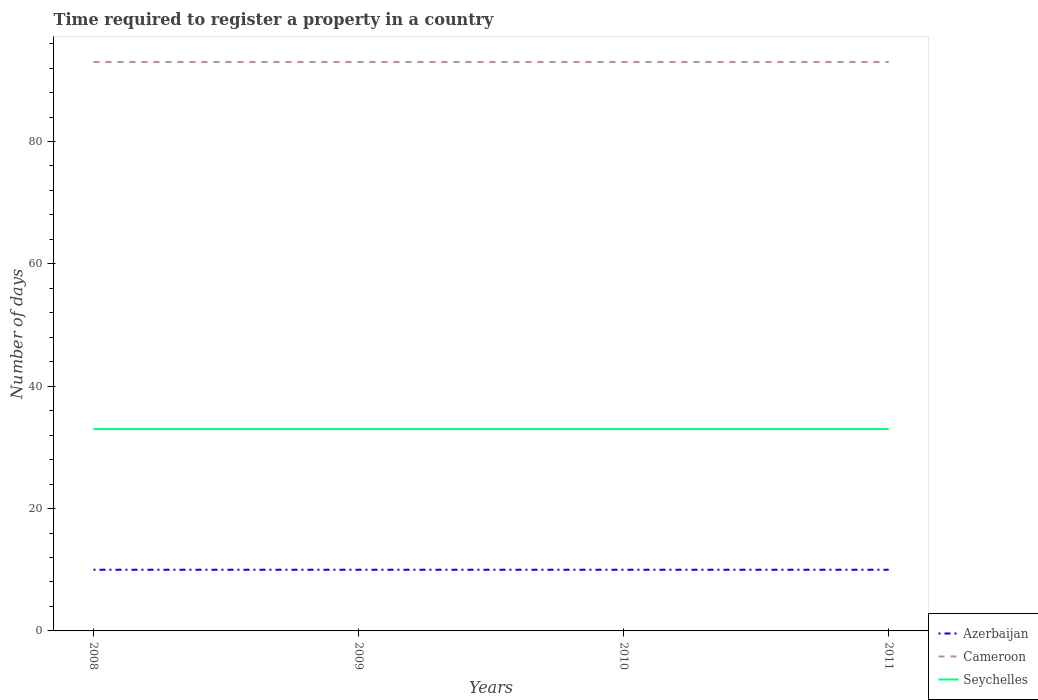How many different coloured lines are there?
Offer a terse response. 3. Is the number of lines equal to the number of legend labels?
Provide a succinct answer. Yes. In which year was the number of days required to register a property in Azerbaijan maximum?
Ensure brevity in your answer.  2008. What is the total number of days required to register a property in Azerbaijan in the graph?
Keep it short and to the point. 0. What is the difference between the highest and the second highest number of days required to register a property in Cameroon?
Make the answer very short. 0. How many lines are there?
Offer a very short reply. 3. How many years are there in the graph?
Provide a succinct answer. 4. What is the difference between two consecutive major ticks on the Y-axis?
Keep it short and to the point. 20. Are the values on the major ticks of Y-axis written in scientific E-notation?
Your response must be concise. No. What is the title of the graph?
Your answer should be compact. Time required to register a property in a country. What is the label or title of the X-axis?
Offer a terse response. Years. What is the label or title of the Y-axis?
Offer a terse response. Number of days. What is the Number of days in Azerbaijan in 2008?
Provide a succinct answer. 10. What is the Number of days in Cameroon in 2008?
Offer a very short reply. 93. What is the Number of days of Cameroon in 2009?
Provide a succinct answer. 93. What is the Number of days in Azerbaijan in 2010?
Offer a terse response. 10. What is the Number of days in Cameroon in 2010?
Provide a short and direct response. 93. What is the Number of days of Azerbaijan in 2011?
Your answer should be very brief. 10. What is the Number of days in Cameroon in 2011?
Your answer should be very brief. 93. Across all years, what is the maximum Number of days in Azerbaijan?
Provide a succinct answer. 10. Across all years, what is the maximum Number of days of Cameroon?
Give a very brief answer. 93. Across all years, what is the minimum Number of days in Azerbaijan?
Make the answer very short. 10. Across all years, what is the minimum Number of days of Cameroon?
Give a very brief answer. 93. Across all years, what is the minimum Number of days of Seychelles?
Provide a succinct answer. 33. What is the total Number of days of Cameroon in the graph?
Make the answer very short. 372. What is the total Number of days of Seychelles in the graph?
Ensure brevity in your answer.  132. What is the difference between the Number of days of Seychelles in 2008 and that in 2009?
Your response must be concise. 0. What is the difference between the Number of days of Azerbaijan in 2008 and that in 2010?
Provide a short and direct response. 0. What is the difference between the Number of days in Cameroon in 2008 and that in 2010?
Keep it short and to the point. 0. What is the difference between the Number of days of Azerbaijan in 2008 and that in 2011?
Your answer should be very brief. 0. What is the difference between the Number of days of Cameroon in 2008 and that in 2011?
Offer a terse response. 0. What is the difference between the Number of days in Azerbaijan in 2009 and that in 2010?
Ensure brevity in your answer.  0. What is the difference between the Number of days of Azerbaijan in 2010 and that in 2011?
Ensure brevity in your answer.  0. What is the difference between the Number of days of Cameroon in 2010 and that in 2011?
Your answer should be compact. 0. What is the difference between the Number of days in Azerbaijan in 2008 and the Number of days in Cameroon in 2009?
Offer a terse response. -83. What is the difference between the Number of days in Azerbaijan in 2008 and the Number of days in Seychelles in 2009?
Ensure brevity in your answer.  -23. What is the difference between the Number of days of Cameroon in 2008 and the Number of days of Seychelles in 2009?
Give a very brief answer. 60. What is the difference between the Number of days in Azerbaijan in 2008 and the Number of days in Cameroon in 2010?
Your response must be concise. -83. What is the difference between the Number of days of Azerbaijan in 2008 and the Number of days of Cameroon in 2011?
Make the answer very short. -83. What is the difference between the Number of days in Cameroon in 2008 and the Number of days in Seychelles in 2011?
Your answer should be very brief. 60. What is the difference between the Number of days of Azerbaijan in 2009 and the Number of days of Cameroon in 2010?
Ensure brevity in your answer.  -83. What is the difference between the Number of days in Azerbaijan in 2009 and the Number of days in Seychelles in 2010?
Make the answer very short. -23. What is the difference between the Number of days of Azerbaijan in 2009 and the Number of days of Cameroon in 2011?
Your answer should be very brief. -83. What is the difference between the Number of days in Azerbaijan in 2009 and the Number of days in Seychelles in 2011?
Offer a very short reply. -23. What is the difference between the Number of days of Azerbaijan in 2010 and the Number of days of Cameroon in 2011?
Provide a succinct answer. -83. What is the average Number of days of Cameroon per year?
Your answer should be compact. 93. What is the average Number of days of Seychelles per year?
Give a very brief answer. 33. In the year 2008, what is the difference between the Number of days in Azerbaijan and Number of days in Cameroon?
Your response must be concise. -83. In the year 2008, what is the difference between the Number of days in Cameroon and Number of days in Seychelles?
Make the answer very short. 60. In the year 2009, what is the difference between the Number of days in Azerbaijan and Number of days in Cameroon?
Your answer should be very brief. -83. In the year 2009, what is the difference between the Number of days of Azerbaijan and Number of days of Seychelles?
Provide a short and direct response. -23. In the year 2009, what is the difference between the Number of days in Cameroon and Number of days in Seychelles?
Make the answer very short. 60. In the year 2010, what is the difference between the Number of days of Azerbaijan and Number of days of Cameroon?
Make the answer very short. -83. In the year 2010, what is the difference between the Number of days of Azerbaijan and Number of days of Seychelles?
Provide a succinct answer. -23. In the year 2010, what is the difference between the Number of days in Cameroon and Number of days in Seychelles?
Make the answer very short. 60. In the year 2011, what is the difference between the Number of days in Azerbaijan and Number of days in Cameroon?
Your answer should be very brief. -83. In the year 2011, what is the difference between the Number of days of Azerbaijan and Number of days of Seychelles?
Your answer should be compact. -23. What is the ratio of the Number of days of Azerbaijan in 2008 to that in 2009?
Provide a succinct answer. 1. What is the ratio of the Number of days of Cameroon in 2008 to that in 2009?
Offer a terse response. 1. What is the ratio of the Number of days of Azerbaijan in 2008 to that in 2010?
Provide a succinct answer. 1. What is the ratio of the Number of days of Cameroon in 2008 to that in 2010?
Give a very brief answer. 1. What is the ratio of the Number of days in Azerbaijan in 2008 to that in 2011?
Your answer should be very brief. 1. What is the ratio of the Number of days of Cameroon in 2008 to that in 2011?
Keep it short and to the point. 1. What is the ratio of the Number of days in Seychelles in 2008 to that in 2011?
Your answer should be compact. 1. What is the ratio of the Number of days of Azerbaijan in 2009 to that in 2010?
Give a very brief answer. 1. What is the ratio of the Number of days of Cameroon in 2009 to that in 2010?
Offer a very short reply. 1. What is the ratio of the Number of days of Seychelles in 2009 to that in 2010?
Your response must be concise. 1. What is the ratio of the Number of days of Azerbaijan in 2009 to that in 2011?
Provide a succinct answer. 1. What is the ratio of the Number of days of Azerbaijan in 2010 to that in 2011?
Offer a terse response. 1. What is the ratio of the Number of days of Cameroon in 2010 to that in 2011?
Make the answer very short. 1. What is the ratio of the Number of days of Seychelles in 2010 to that in 2011?
Make the answer very short. 1. What is the difference between the highest and the second highest Number of days of Cameroon?
Offer a very short reply. 0. 